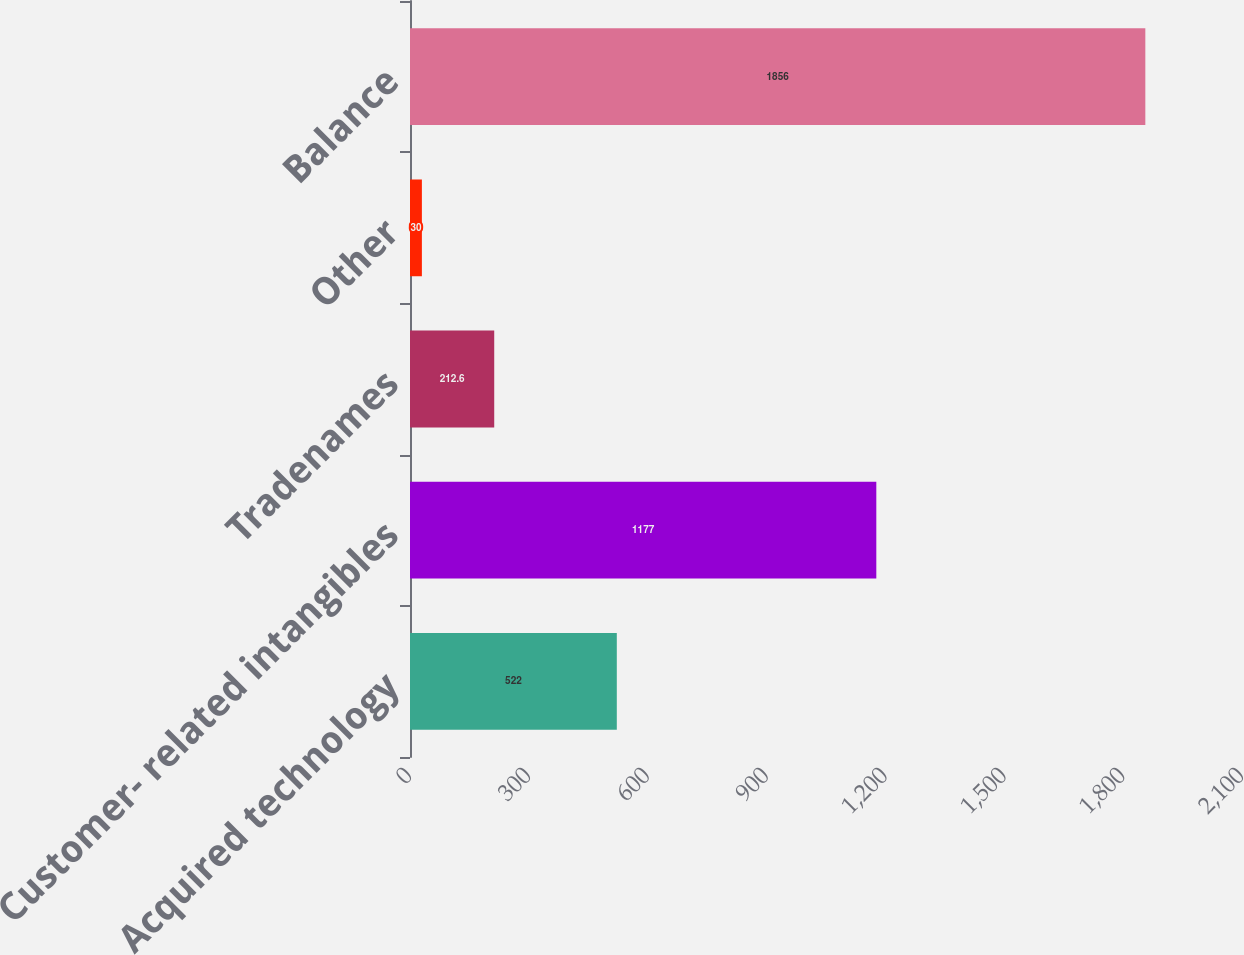Convert chart to OTSL. <chart><loc_0><loc_0><loc_500><loc_500><bar_chart><fcel>Acquired technology<fcel>Customer- related intangibles<fcel>Tradenames<fcel>Other<fcel>Balance<nl><fcel>522<fcel>1177<fcel>212.6<fcel>30<fcel>1856<nl></chart> 